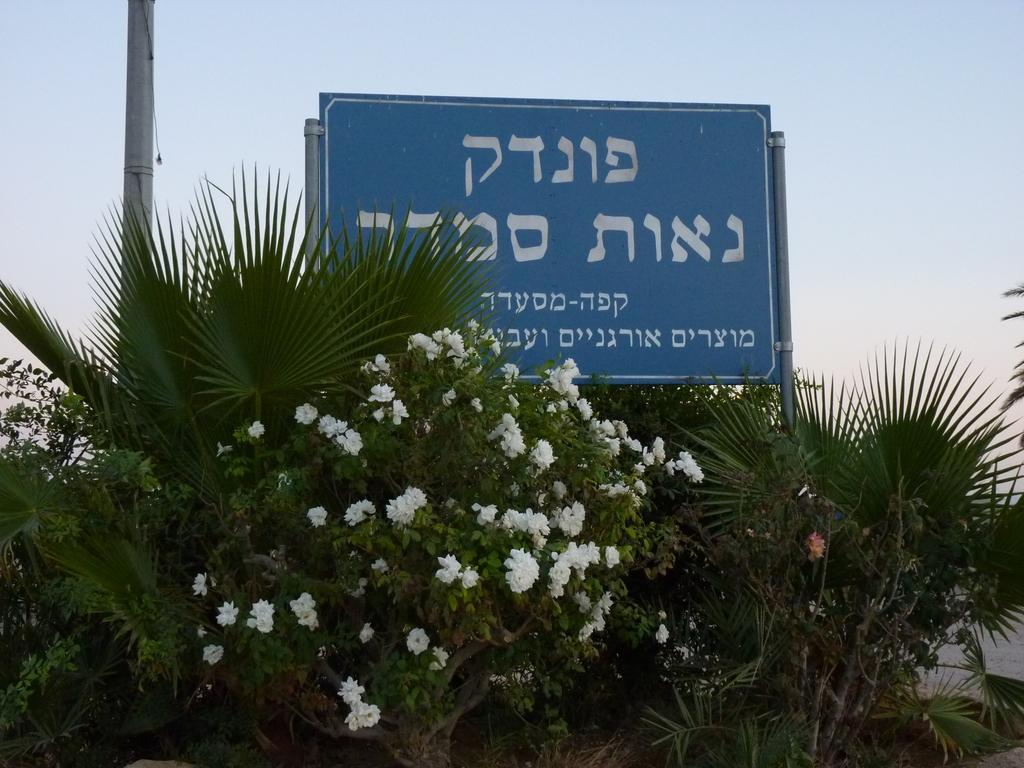Describe this image in one or two sentences. In the image we can see a plant and white flowers. Here we can see a board, blue in color, on the board there is a white color text. Here we can see a pole and a sky. 